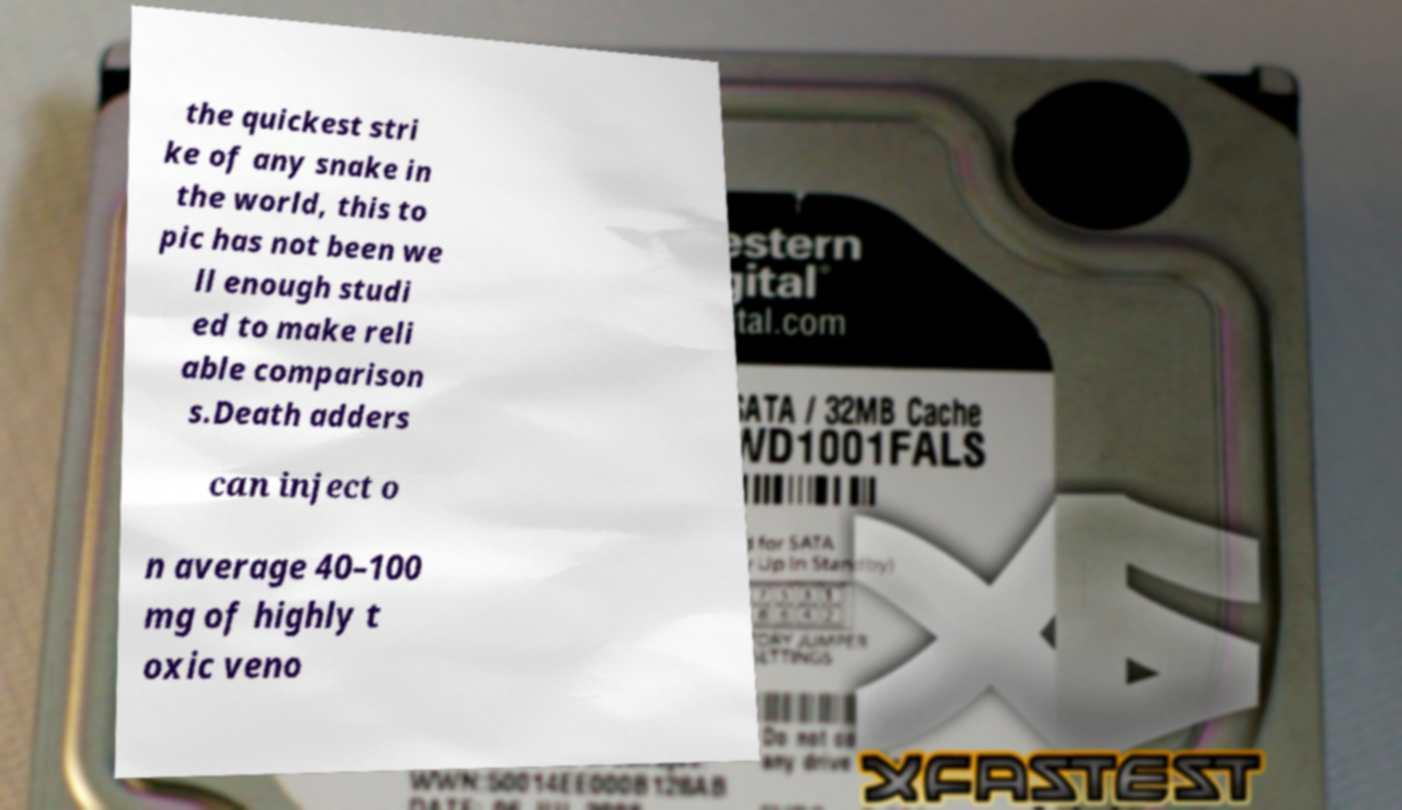For documentation purposes, I need the text within this image transcribed. Could you provide that? the quickest stri ke of any snake in the world, this to pic has not been we ll enough studi ed to make reli able comparison s.Death adders can inject o n average 40–100 mg of highly t oxic veno 